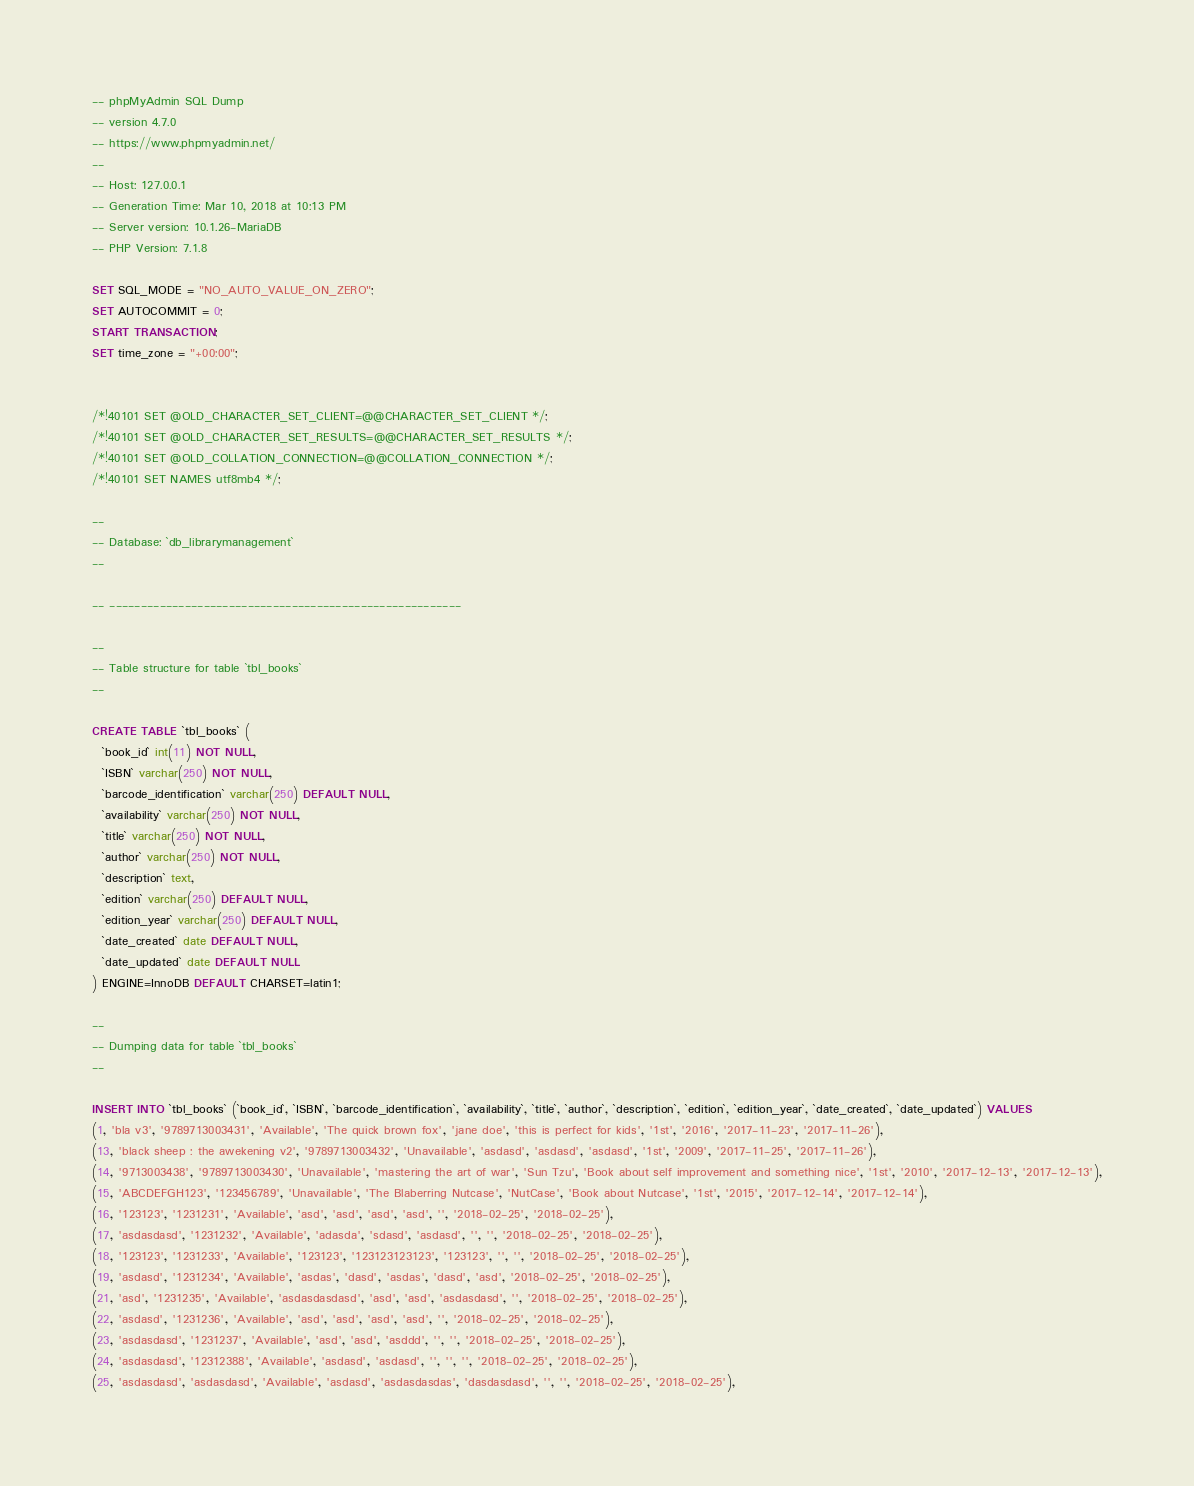<code> <loc_0><loc_0><loc_500><loc_500><_SQL_>-- phpMyAdmin SQL Dump
-- version 4.7.0
-- https://www.phpmyadmin.net/
--
-- Host: 127.0.0.1
-- Generation Time: Mar 10, 2018 at 10:13 PM
-- Server version: 10.1.26-MariaDB
-- PHP Version: 7.1.8

SET SQL_MODE = "NO_AUTO_VALUE_ON_ZERO";
SET AUTOCOMMIT = 0;
START TRANSACTION;
SET time_zone = "+00:00";


/*!40101 SET @OLD_CHARACTER_SET_CLIENT=@@CHARACTER_SET_CLIENT */;
/*!40101 SET @OLD_CHARACTER_SET_RESULTS=@@CHARACTER_SET_RESULTS */;
/*!40101 SET @OLD_COLLATION_CONNECTION=@@COLLATION_CONNECTION */;
/*!40101 SET NAMES utf8mb4 */;

--
-- Database: `db_librarymanagement`
--

-- --------------------------------------------------------

--
-- Table structure for table `tbl_books`
--

CREATE TABLE `tbl_books` (
  `book_id` int(11) NOT NULL,
  `ISBN` varchar(250) NOT NULL,
  `barcode_identification` varchar(250) DEFAULT NULL,
  `availability` varchar(250) NOT NULL,
  `title` varchar(250) NOT NULL,
  `author` varchar(250) NOT NULL,
  `description` text,
  `edition` varchar(250) DEFAULT NULL,
  `edition_year` varchar(250) DEFAULT NULL,
  `date_created` date DEFAULT NULL,
  `date_updated` date DEFAULT NULL
) ENGINE=InnoDB DEFAULT CHARSET=latin1;

--
-- Dumping data for table `tbl_books`
--

INSERT INTO `tbl_books` (`book_id`, `ISBN`, `barcode_identification`, `availability`, `title`, `author`, `description`, `edition`, `edition_year`, `date_created`, `date_updated`) VALUES
(1, 'bla v3', '9789713003431', 'Available', 'The quick brown fox', 'jane doe', 'this is perfect for kids', '1st', '2016', '2017-11-23', '2017-11-26'),
(13, 'black sheep : the awekening v2', '9789713003432', 'Unavailable', 'asdasd', 'asdasd', 'asdasd', '1st', '2009', '2017-11-25', '2017-11-26'),
(14, '9713003438', '9789713003430', 'Unavailable', 'mastering the art of war', 'Sun Tzu', 'Book about self improvement and something nice', '1st', '2010', '2017-12-13', '2017-12-13'),
(15, 'ABCDEFGH123', '123456789', 'Unavailable', 'The Blaberring Nutcase', 'NutCase', 'Book about Nutcase', '1st', '2015', '2017-12-14', '2017-12-14'),
(16, '123123', '1231231', 'Available', 'asd', 'asd', 'asd', 'asd', '', '2018-02-25', '2018-02-25'),
(17, 'asdasdasd', '1231232', 'Available', 'adasda', 'sdasd', 'asdasd', '', '', '2018-02-25', '2018-02-25'),
(18, '123123', '1231233', 'Available', '123123', '123123123123', '123123', '', '', '2018-02-25', '2018-02-25'),
(19, 'asdasd', '1231234', 'Available', 'asdas', 'dasd', 'asdas', 'dasd', 'asd', '2018-02-25', '2018-02-25'),
(21, 'asd', '1231235', 'Available', 'asdasdasdasd', 'asd', 'asd', 'asdasdasd', '', '2018-02-25', '2018-02-25'),
(22, 'asdasd', '1231236', 'Available', 'asd', 'asd', 'asd', 'asd', '', '2018-02-25', '2018-02-25'),
(23, 'asdasdasd', '1231237', 'Available', 'asd', 'asd', 'asddd', '', '', '2018-02-25', '2018-02-25'),
(24, 'asdasdasd', '12312388', 'Available', 'asdasd', 'asdasd', '', '', '', '2018-02-25', '2018-02-25'),
(25, 'asdasdasd', 'asdasdasd', 'Available', 'asdasd', 'asdasdasdas', 'dasdasdasd', '', '', '2018-02-25', '2018-02-25'),</code> 